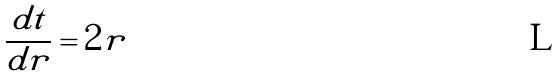<formula> <loc_0><loc_0><loc_500><loc_500>\frac { d t } { d r } = 2 r</formula> 